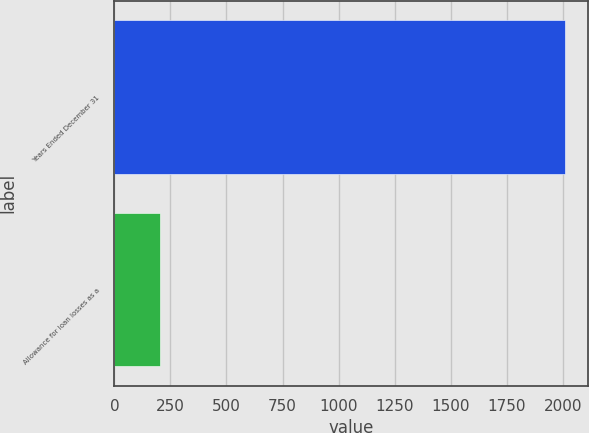Convert chart to OTSL. <chart><loc_0><loc_0><loc_500><loc_500><bar_chart><fcel>Years Ended December 31<fcel>Allowance for loan losses as a<nl><fcel>2011<fcel>202.63<nl></chart> 